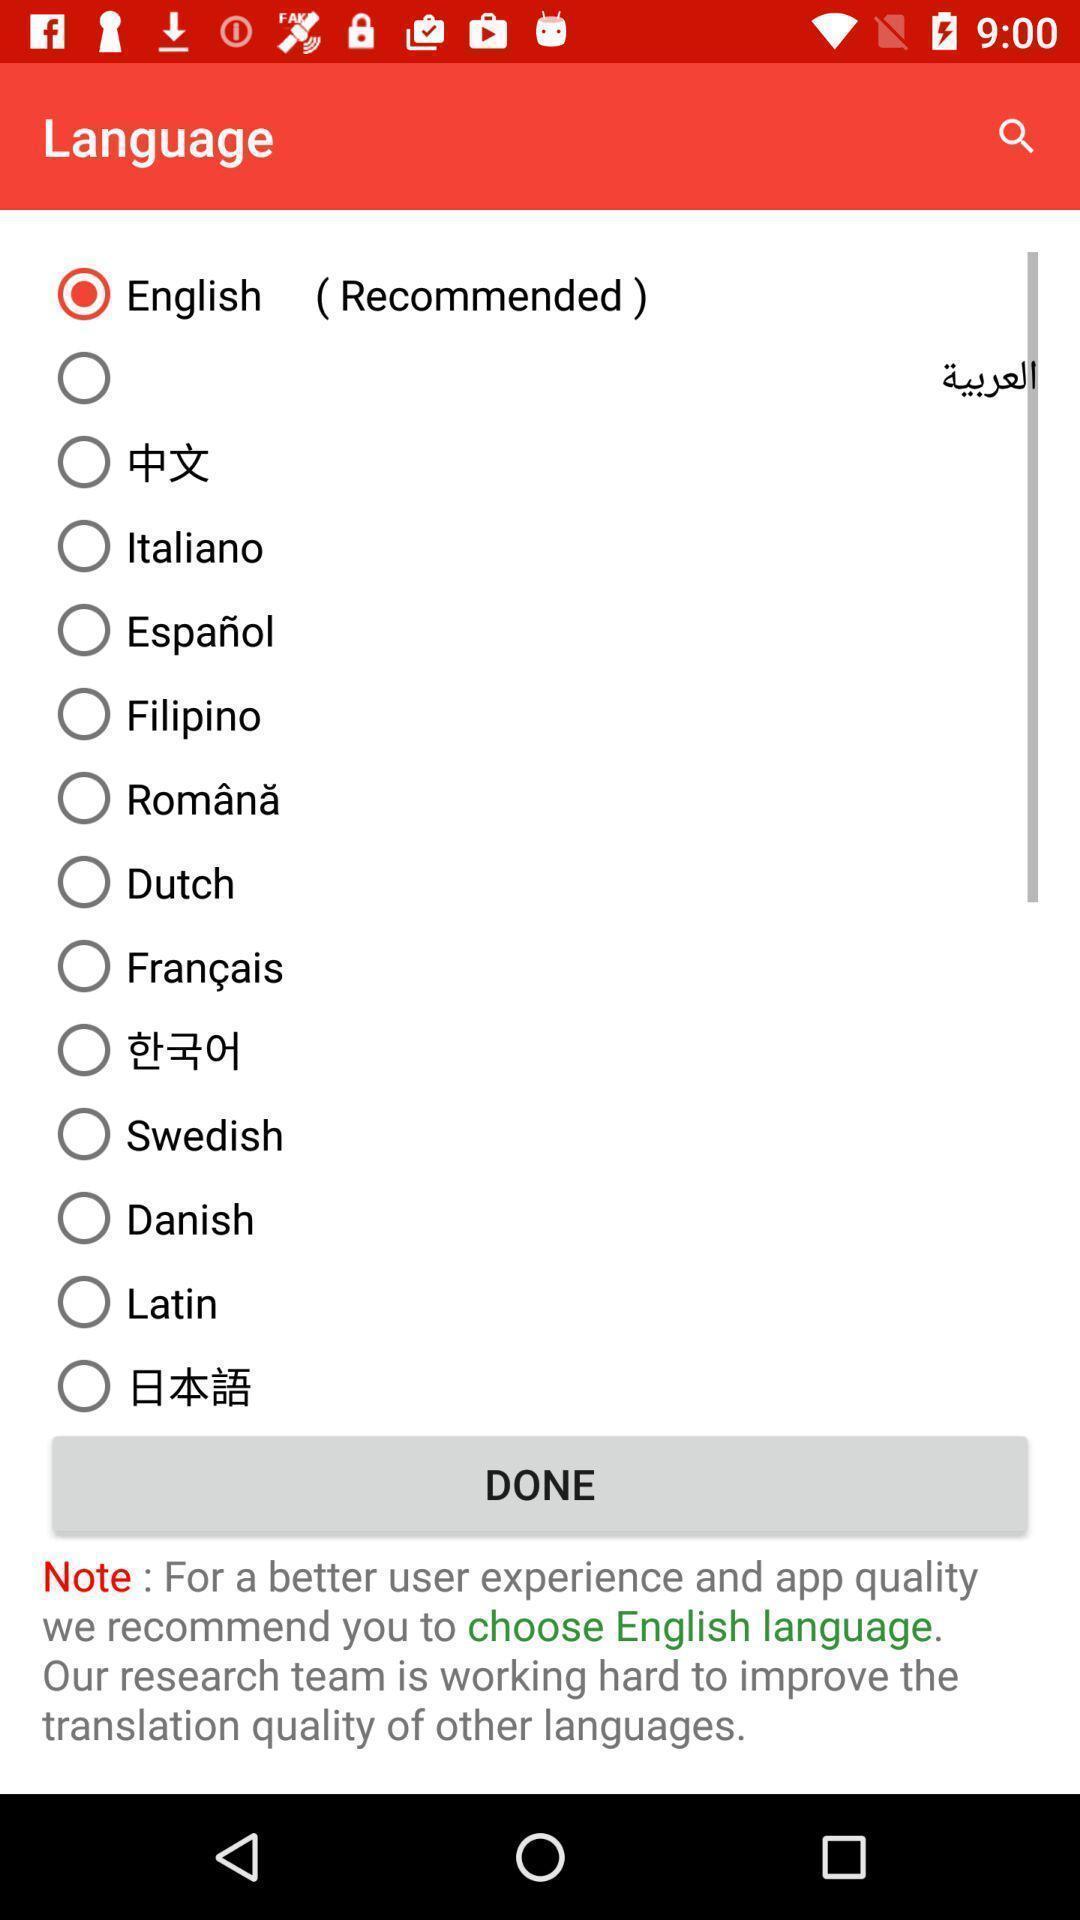Explain the elements present in this screenshot. Page showing different languages to select. 